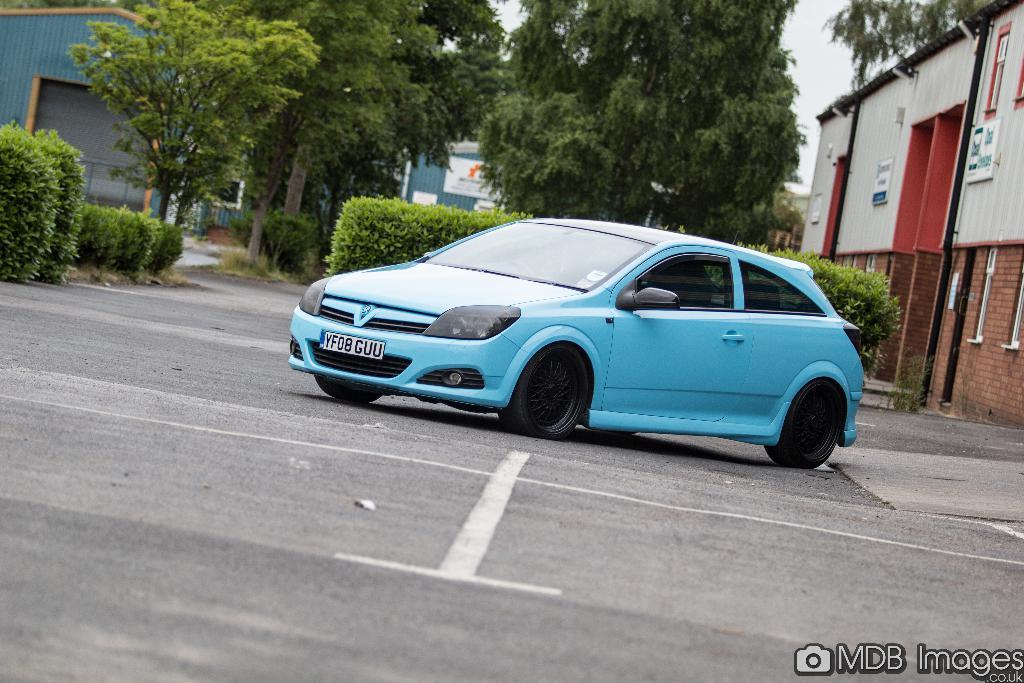What type of natural elements can be seen in the image? There are trees and plants in the image. What type of structures are present in the image? There are sheds in the image. What is the main object in the middle of the image? There is a car in the middle of the image. Where can text be found in the image? Text can be found in the bottom right of the image. What flavor of ice cream is the car attracting in the image? There is no ice cream or indication of flavor in the image. The car is not attracting any ice cream. 